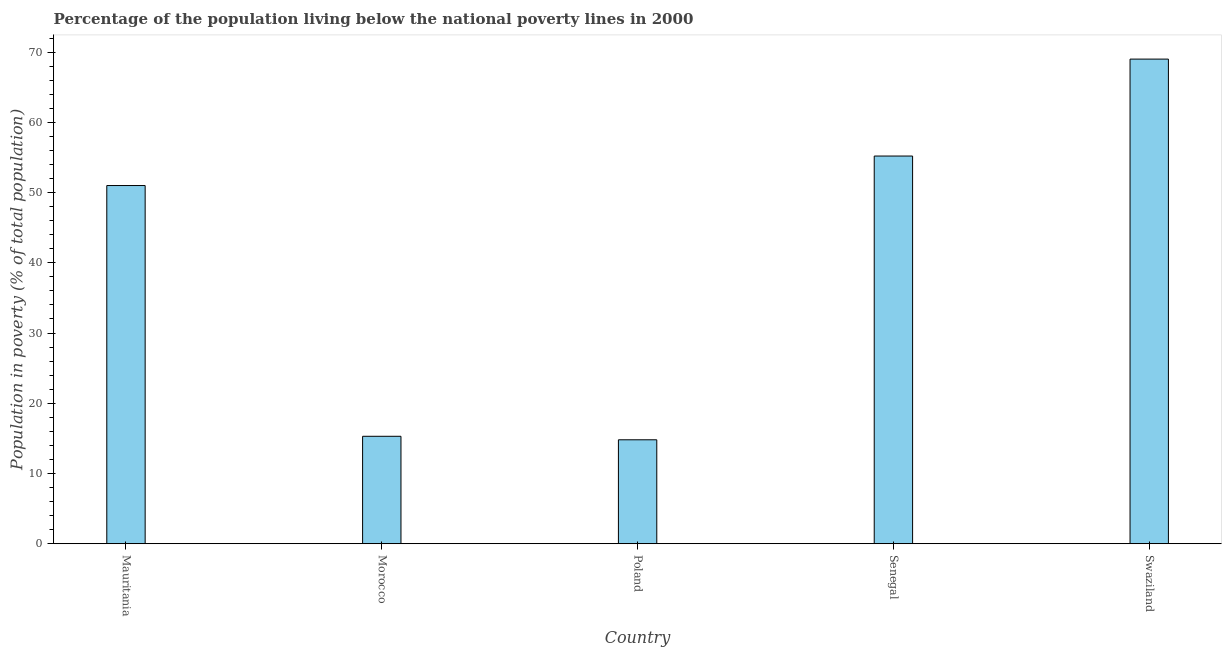Does the graph contain grids?
Your response must be concise. No. What is the title of the graph?
Keep it short and to the point. Percentage of the population living below the national poverty lines in 2000. What is the label or title of the Y-axis?
Make the answer very short. Population in poverty (% of total population). Across all countries, what is the maximum percentage of population living below poverty line?
Ensure brevity in your answer.  69. In which country was the percentage of population living below poverty line maximum?
Keep it short and to the point. Swaziland. In which country was the percentage of population living below poverty line minimum?
Provide a succinct answer. Poland. What is the sum of the percentage of population living below poverty line?
Give a very brief answer. 205.3. What is the difference between the percentage of population living below poverty line in Mauritania and Poland?
Provide a short and direct response. 36.2. What is the average percentage of population living below poverty line per country?
Offer a terse response. 41.06. What is the median percentage of population living below poverty line?
Offer a very short reply. 51. What is the ratio of the percentage of population living below poverty line in Poland to that in Senegal?
Provide a succinct answer. 0.27. Is the percentage of population living below poverty line in Morocco less than that in Poland?
Make the answer very short. No. Is the difference between the percentage of population living below poverty line in Morocco and Poland greater than the difference between any two countries?
Keep it short and to the point. No. What is the difference between the highest and the second highest percentage of population living below poverty line?
Your response must be concise. 13.8. What is the difference between the highest and the lowest percentage of population living below poverty line?
Offer a very short reply. 54.2. How many bars are there?
Offer a terse response. 5. Are all the bars in the graph horizontal?
Provide a short and direct response. No. How many countries are there in the graph?
Your answer should be compact. 5. What is the Population in poverty (% of total population) of Mauritania?
Offer a very short reply. 51. What is the Population in poverty (% of total population) in Poland?
Make the answer very short. 14.8. What is the Population in poverty (% of total population) in Senegal?
Ensure brevity in your answer.  55.2. What is the difference between the Population in poverty (% of total population) in Mauritania and Morocco?
Your answer should be compact. 35.7. What is the difference between the Population in poverty (% of total population) in Mauritania and Poland?
Provide a short and direct response. 36.2. What is the difference between the Population in poverty (% of total population) in Morocco and Senegal?
Give a very brief answer. -39.9. What is the difference between the Population in poverty (% of total population) in Morocco and Swaziland?
Provide a short and direct response. -53.7. What is the difference between the Population in poverty (% of total population) in Poland and Senegal?
Give a very brief answer. -40.4. What is the difference between the Population in poverty (% of total population) in Poland and Swaziland?
Offer a terse response. -54.2. What is the ratio of the Population in poverty (% of total population) in Mauritania to that in Morocco?
Provide a succinct answer. 3.33. What is the ratio of the Population in poverty (% of total population) in Mauritania to that in Poland?
Give a very brief answer. 3.45. What is the ratio of the Population in poverty (% of total population) in Mauritania to that in Senegal?
Keep it short and to the point. 0.92. What is the ratio of the Population in poverty (% of total population) in Mauritania to that in Swaziland?
Provide a short and direct response. 0.74. What is the ratio of the Population in poverty (% of total population) in Morocco to that in Poland?
Ensure brevity in your answer.  1.03. What is the ratio of the Population in poverty (% of total population) in Morocco to that in Senegal?
Offer a very short reply. 0.28. What is the ratio of the Population in poverty (% of total population) in Morocco to that in Swaziland?
Provide a succinct answer. 0.22. What is the ratio of the Population in poverty (% of total population) in Poland to that in Senegal?
Give a very brief answer. 0.27. What is the ratio of the Population in poverty (% of total population) in Poland to that in Swaziland?
Make the answer very short. 0.21. What is the ratio of the Population in poverty (% of total population) in Senegal to that in Swaziland?
Make the answer very short. 0.8. 